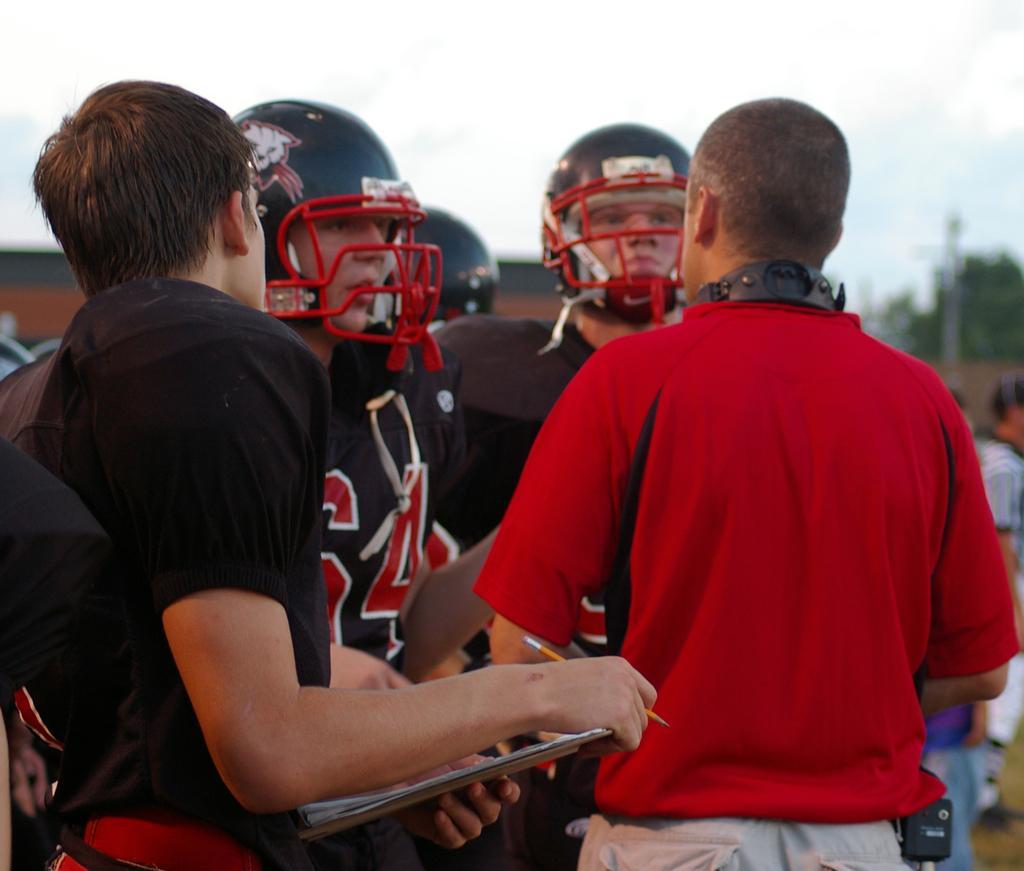Can you describe this image briefly? In this picture I can see few people among them some people are wearing helmet, behind we can see few people, trees, buildings. 